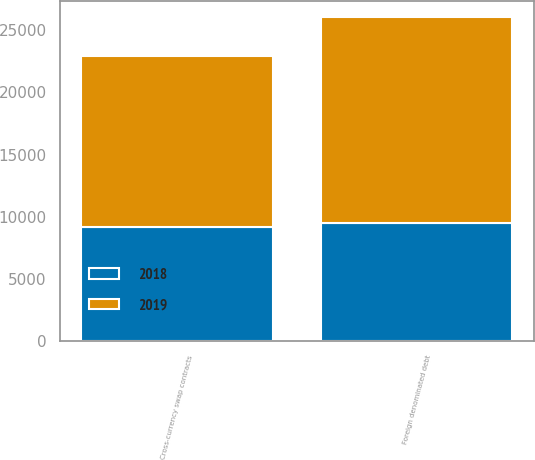<chart> <loc_0><loc_0><loc_500><loc_500><stacked_bar_chart><ecel><fcel>Cross-currency swap contracts<fcel>Foreign denominated debt<nl><fcel>2019<fcel>13723<fcel>16458<nl><fcel>2018<fcel>9209<fcel>9543<nl></chart> 